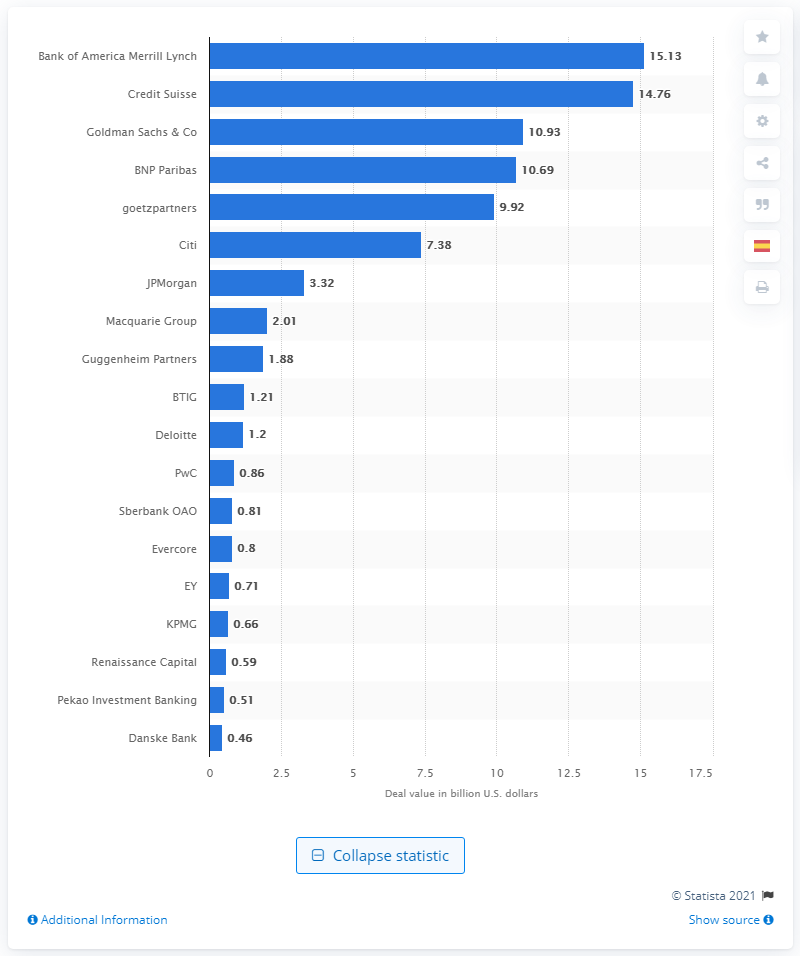Give some essential details in this illustration. The deal value of Bank of America Merrill Lynch in the first half of 2019 was 15.13. 